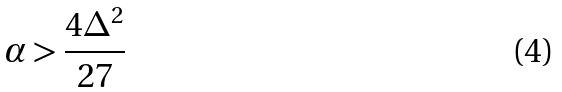Convert formula to latex. <formula><loc_0><loc_0><loc_500><loc_500>\alpha > \frac { 4 \Delta ^ { 2 } } { 2 7 }</formula> 